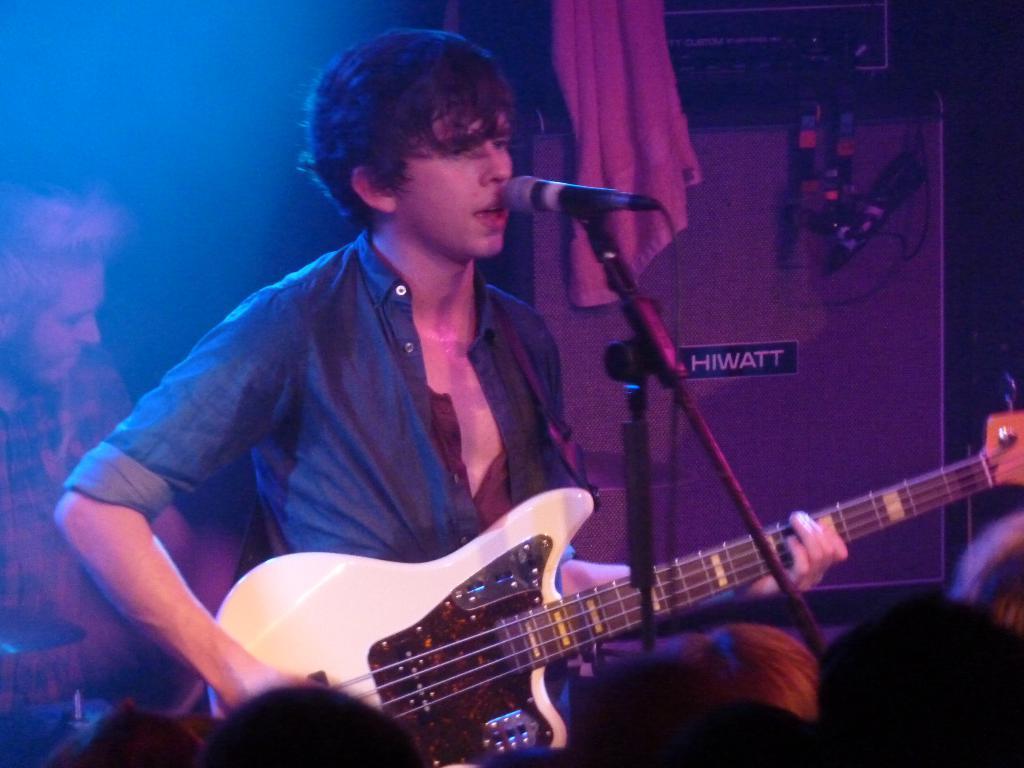How would you summarize this image in a sentence or two? In this picture there is a man who is wearing shirt and trouser. He is playing guitar and singing on the mic. On the left we can see another man who is playing the drums. At the bottom we can see the audience. In the background we can see the musical instrument and the towel. 